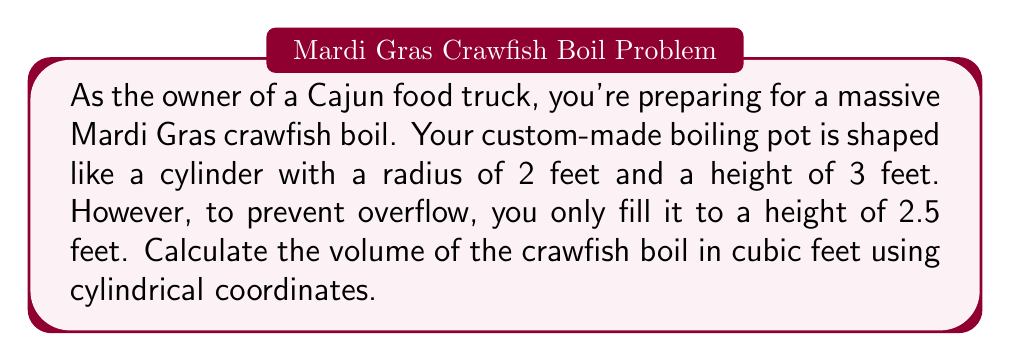Teach me how to tackle this problem. To solve this problem, we'll use cylindrical coordinates and follow these steps:

1) In cylindrical coordinates, the volume of a solid is given by the triple integral:

   $$V = \int_{0}^{2\pi} \int_{0}^{r} \int_{0}^{h} \rho \, dz \, d\rho \, d\theta$$

   Where $\theta$ is the angular coordinate, $\rho$ is the radial coordinate, and $z$ is the height.

2) For our crawfish pot:
   - The radius $r = 2$ feet
   - The filled height $h = 2.5$ feet
   - $\theta$ goes from 0 to $2\pi$

3) Substituting these values:

   $$V = \int_{0}^{2\pi} \int_{0}^{2} \int_{0}^{2.5} \rho \, dz \, d\rho \, d\theta$$

4) Integrate with respect to $z$:

   $$V = \int_{0}^{2\pi} \int_{0}^{2} \rho \cdot 2.5 \, d\rho \, d\theta$$

5) Integrate with respect to $\rho$:

   $$V = \int_{0}^{2\pi} \left[ \frac{2.5\rho^2}{2} \right]_{0}^{2} \, d\theta = \int_{0}^{2\pi} 5 \, d\theta$$

6) Finally, integrate with respect to $\theta$:

   $$V = 5 \cdot 2\pi = 10\pi$$

Therefore, the volume of the crawfish boil is $10\pi$ cubic feet.
Answer: $10\pi$ cubic feet 